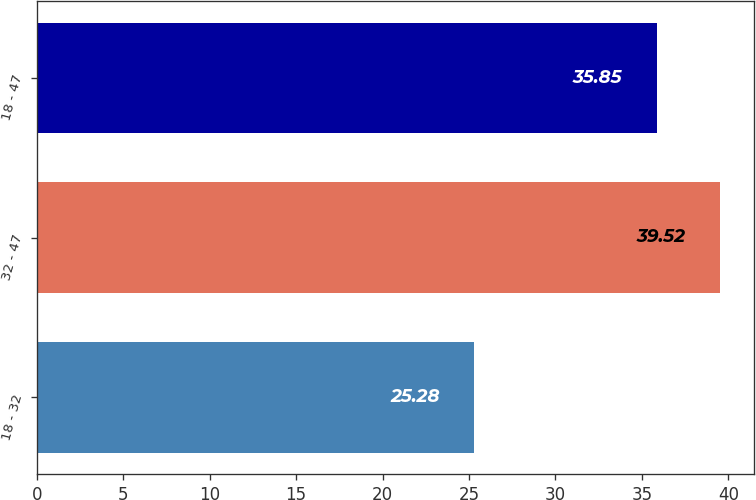<chart> <loc_0><loc_0><loc_500><loc_500><bar_chart><fcel>18 - 32<fcel>32 - 47<fcel>18 - 47<nl><fcel>25.28<fcel>39.52<fcel>35.85<nl></chart> 